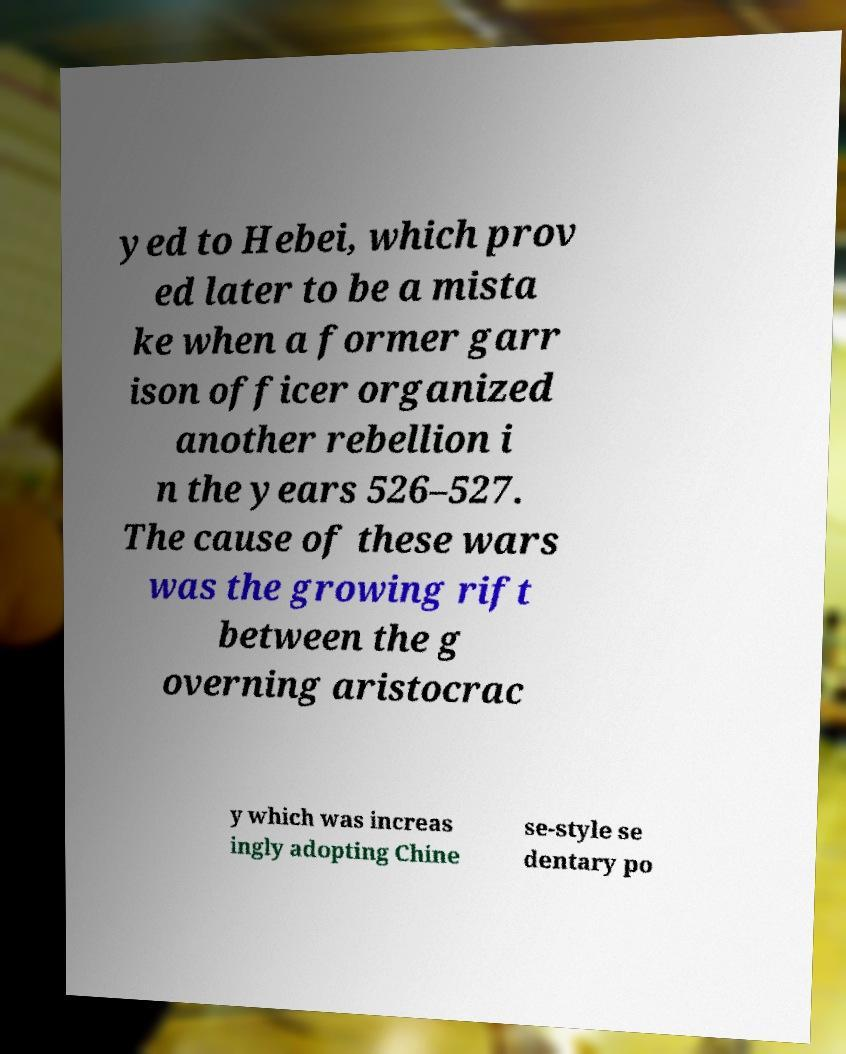Can you accurately transcribe the text from the provided image for me? yed to Hebei, which prov ed later to be a mista ke when a former garr ison officer organized another rebellion i n the years 526–527. The cause of these wars was the growing rift between the g overning aristocrac y which was increas ingly adopting Chine se-style se dentary po 